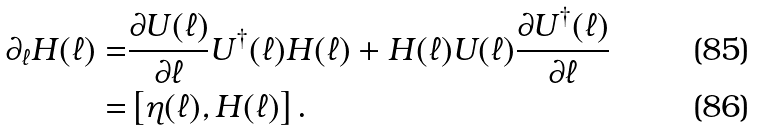Convert formula to latex. <formula><loc_0><loc_0><loc_500><loc_500>\partial _ { \ell } H ( \ell ) = & \frac { \partial U ( \ell ) } { \partial \ell } U ^ { \dagger } ( \ell ) H ( \ell ) + H ( \ell ) U ( \ell ) \frac { \partial U ^ { \dagger } ( \ell ) } { \partial \ell } \\ = & \left [ \eta ( \ell ) , H ( \ell ) \right ] .</formula> 